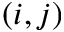Convert formula to latex. <formula><loc_0><loc_0><loc_500><loc_500>( i , j )</formula> 